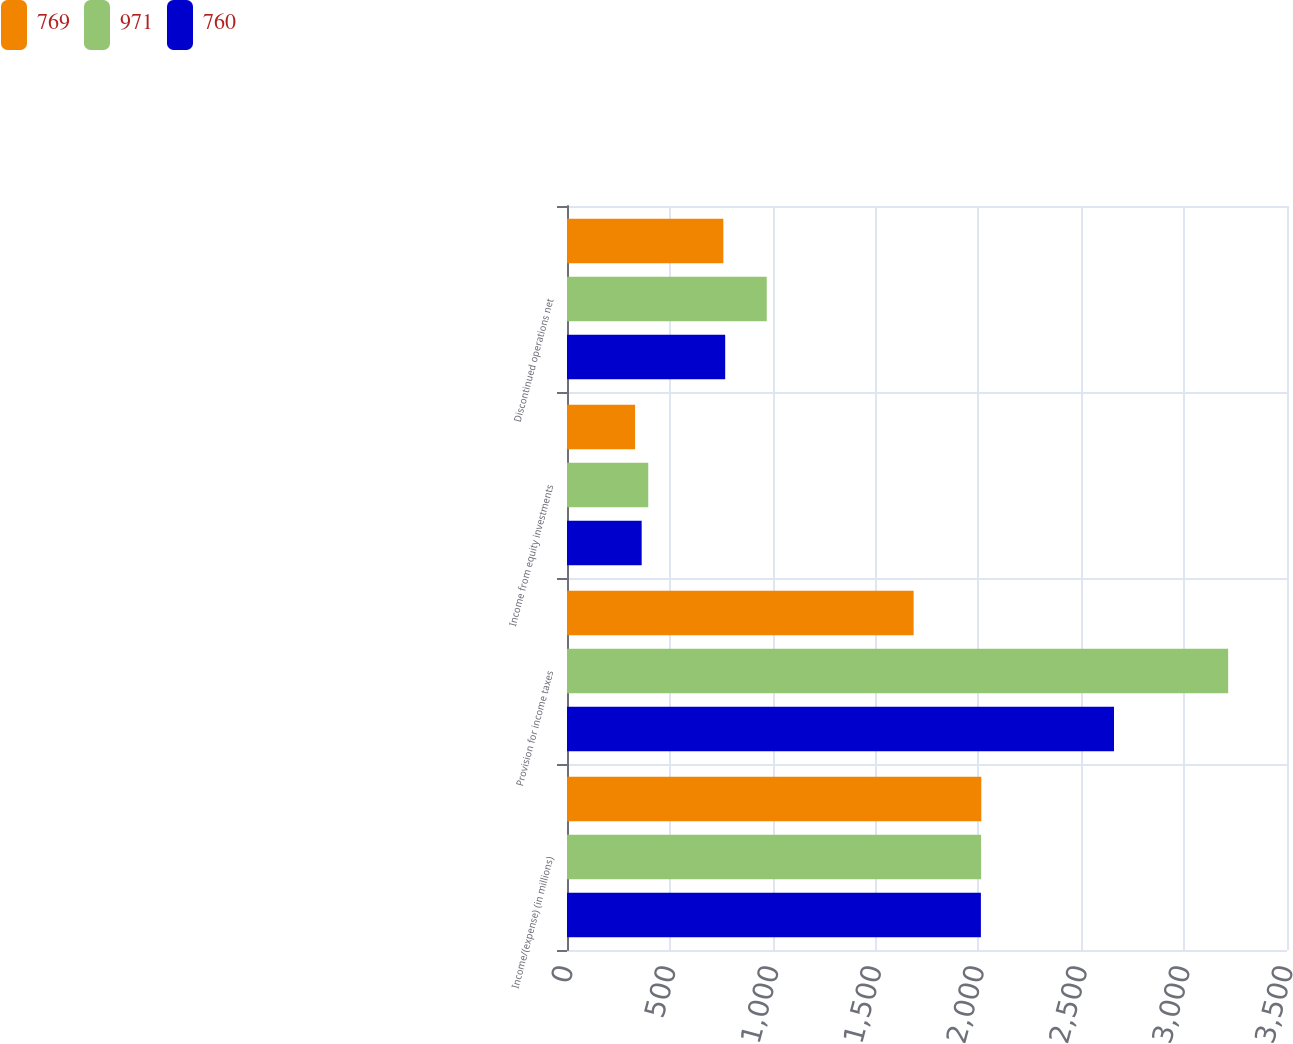Convert chart to OTSL. <chart><loc_0><loc_0><loc_500><loc_500><stacked_bar_chart><ecel><fcel>Income/(expense) (in millions)<fcel>Provision for income taxes<fcel>Income from equity investments<fcel>Discontinued operations net<nl><fcel>769<fcel>2014<fcel>1685<fcel>331<fcel>760<nl><fcel>971<fcel>2013<fcel>3214<fcel>395<fcel>971<nl><fcel>760<fcel>2012<fcel>2659<fcel>363<fcel>769<nl></chart> 